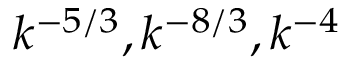<formula> <loc_0><loc_0><loc_500><loc_500>k ^ { - 5 / 3 } , k ^ { - 8 / 3 } , k ^ { - 4 }</formula> 